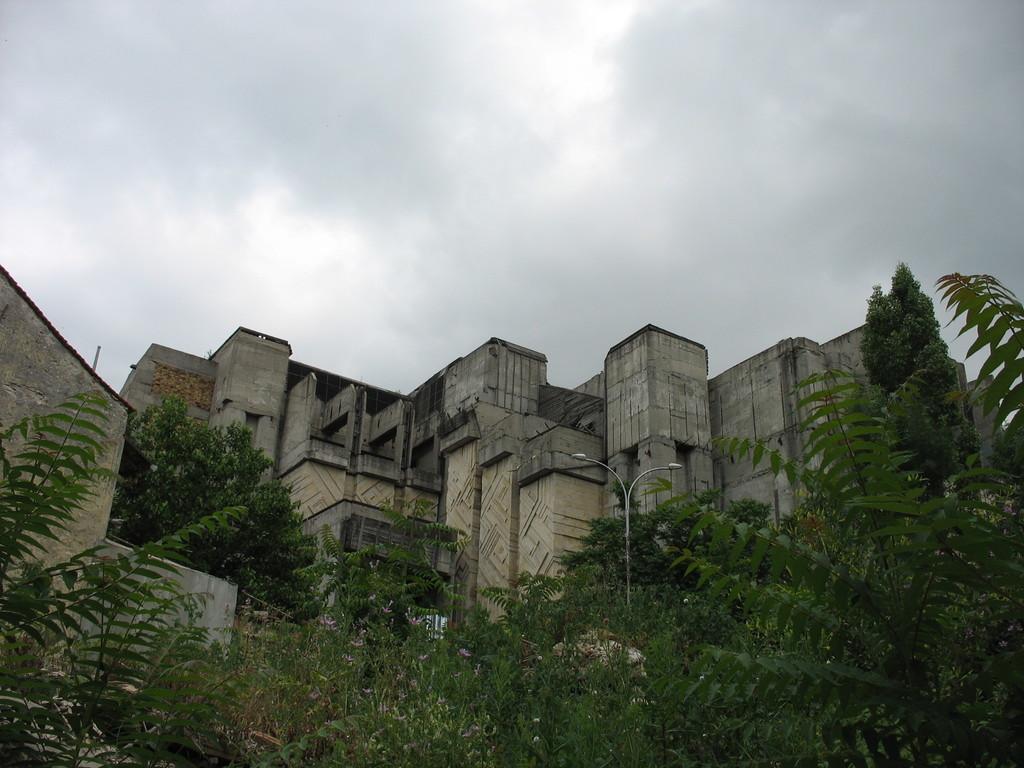Describe this image in one or two sentences. In the picture I can see trees, light poles, buildings and the cloudy sky in the background. 